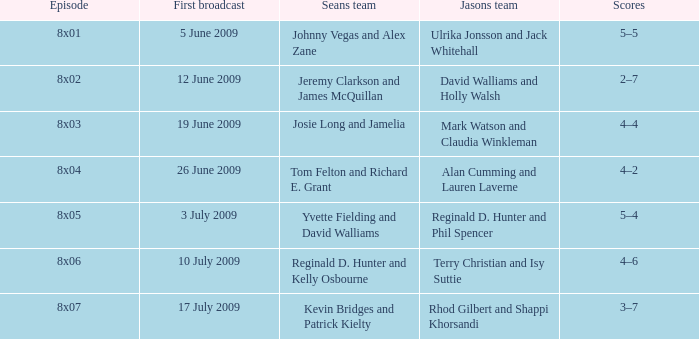What is the broadcast date where Jason's team is Rhod Gilbert and Shappi Khorsandi? 17 July 2009. 